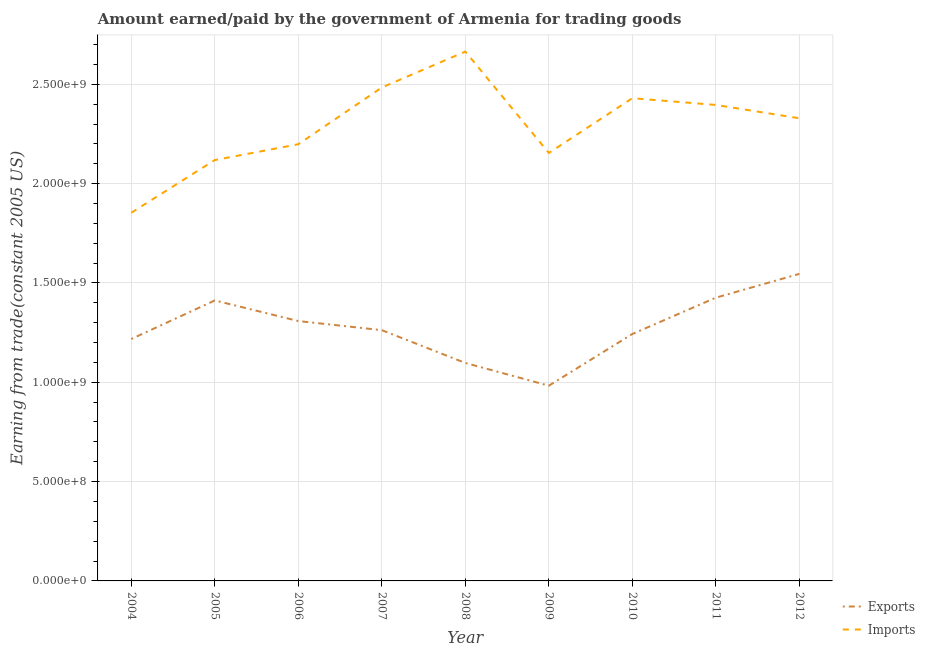Does the line corresponding to amount earned from exports intersect with the line corresponding to amount paid for imports?
Keep it short and to the point. No. What is the amount earned from exports in 2011?
Offer a terse response. 1.43e+09. Across all years, what is the maximum amount paid for imports?
Your answer should be very brief. 2.66e+09. Across all years, what is the minimum amount earned from exports?
Offer a terse response. 9.83e+08. In which year was the amount paid for imports minimum?
Make the answer very short. 2004. What is the total amount earned from exports in the graph?
Offer a terse response. 1.15e+1. What is the difference between the amount paid for imports in 2004 and that in 2009?
Your response must be concise. -3.01e+08. What is the difference between the amount earned from exports in 2010 and the amount paid for imports in 2007?
Your answer should be compact. -1.24e+09. What is the average amount paid for imports per year?
Ensure brevity in your answer.  2.29e+09. In the year 2009, what is the difference between the amount earned from exports and amount paid for imports?
Make the answer very short. -1.17e+09. In how many years, is the amount earned from exports greater than 1300000000 US$?
Keep it short and to the point. 4. What is the ratio of the amount paid for imports in 2008 to that in 2009?
Offer a terse response. 1.24. What is the difference between the highest and the second highest amount earned from exports?
Your response must be concise. 1.20e+08. What is the difference between the highest and the lowest amount earned from exports?
Ensure brevity in your answer.  5.63e+08. Is the sum of the amount earned from exports in 2004 and 2008 greater than the maximum amount paid for imports across all years?
Provide a succinct answer. No. Does the amount paid for imports monotonically increase over the years?
Provide a short and direct response. No. Is the amount earned from exports strictly greater than the amount paid for imports over the years?
Your answer should be compact. No. How many years are there in the graph?
Ensure brevity in your answer.  9. What is the difference between two consecutive major ticks on the Y-axis?
Ensure brevity in your answer.  5.00e+08. Where does the legend appear in the graph?
Provide a succinct answer. Bottom right. How many legend labels are there?
Offer a very short reply. 2. What is the title of the graph?
Give a very brief answer. Amount earned/paid by the government of Armenia for trading goods. Does "Time to import" appear as one of the legend labels in the graph?
Offer a terse response. No. What is the label or title of the Y-axis?
Provide a succinct answer. Earning from trade(constant 2005 US). What is the Earning from trade(constant 2005 US) of Exports in 2004?
Give a very brief answer. 1.22e+09. What is the Earning from trade(constant 2005 US) of Imports in 2004?
Provide a succinct answer. 1.85e+09. What is the Earning from trade(constant 2005 US) in Exports in 2005?
Give a very brief answer. 1.41e+09. What is the Earning from trade(constant 2005 US) in Imports in 2005?
Offer a very short reply. 2.12e+09. What is the Earning from trade(constant 2005 US) of Exports in 2006?
Your answer should be very brief. 1.31e+09. What is the Earning from trade(constant 2005 US) in Imports in 2006?
Your answer should be compact. 2.20e+09. What is the Earning from trade(constant 2005 US) of Exports in 2007?
Your response must be concise. 1.26e+09. What is the Earning from trade(constant 2005 US) of Imports in 2007?
Ensure brevity in your answer.  2.48e+09. What is the Earning from trade(constant 2005 US) of Exports in 2008?
Provide a short and direct response. 1.10e+09. What is the Earning from trade(constant 2005 US) of Imports in 2008?
Ensure brevity in your answer.  2.66e+09. What is the Earning from trade(constant 2005 US) in Exports in 2009?
Provide a succinct answer. 9.83e+08. What is the Earning from trade(constant 2005 US) of Imports in 2009?
Your response must be concise. 2.15e+09. What is the Earning from trade(constant 2005 US) of Exports in 2010?
Provide a succinct answer. 1.24e+09. What is the Earning from trade(constant 2005 US) of Imports in 2010?
Your answer should be very brief. 2.43e+09. What is the Earning from trade(constant 2005 US) of Exports in 2011?
Provide a short and direct response. 1.43e+09. What is the Earning from trade(constant 2005 US) in Imports in 2011?
Your answer should be very brief. 2.40e+09. What is the Earning from trade(constant 2005 US) in Exports in 2012?
Offer a terse response. 1.55e+09. What is the Earning from trade(constant 2005 US) of Imports in 2012?
Give a very brief answer. 2.33e+09. Across all years, what is the maximum Earning from trade(constant 2005 US) in Exports?
Provide a short and direct response. 1.55e+09. Across all years, what is the maximum Earning from trade(constant 2005 US) in Imports?
Keep it short and to the point. 2.66e+09. Across all years, what is the minimum Earning from trade(constant 2005 US) in Exports?
Make the answer very short. 9.83e+08. Across all years, what is the minimum Earning from trade(constant 2005 US) in Imports?
Provide a short and direct response. 1.85e+09. What is the total Earning from trade(constant 2005 US) of Exports in the graph?
Keep it short and to the point. 1.15e+1. What is the total Earning from trade(constant 2005 US) in Imports in the graph?
Provide a short and direct response. 2.06e+1. What is the difference between the Earning from trade(constant 2005 US) of Exports in 2004 and that in 2005?
Provide a short and direct response. -1.94e+08. What is the difference between the Earning from trade(constant 2005 US) of Imports in 2004 and that in 2005?
Your answer should be compact. -2.65e+08. What is the difference between the Earning from trade(constant 2005 US) in Exports in 2004 and that in 2006?
Ensure brevity in your answer.  -9.05e+07. What is the difference between the Earning from trade(constant 2005 US) of Imports in 2004 and that in 2006?
Offer a terse response. -3.45e+08. What is the difference between the Earning from trade(constant 2005 US) in Exports in 2004 and that in 2007?
Your response must be concise. -4.46e+07. What is the difference between the Earning from trade(constant 2005 US) of Imports in 2004 and that in 2007?
Your answer should be compact. -6.30e+08. What is the difference between the Earning from trade(constant 2005 US) in Exports in 2004 and that in 2008?
Offer a very short reply. 1.21e+08. What is the difference between the Earning from trade(constant 2005 US) in Imports in 2004 and that in 2008?
Your response must be concise. -8.11e+08. What is the difference between the Earning from trade(constant 2005 US) of Exports in 2004 and that in 2009?
Give a very brief answer. 2.35e+08. What is the difference between the Earning from trade(constant 2005 US) in Imports in 2004 and that in 2009?
Keep it short and to the point. -3.01e+08. What is the difference between the Earning from trade(constant 2005 US) in Exports in 2004 and that in 2010?
Give a very brief answer. -2.54e+07. What is the difference between the Earning from trade(constant 2005 US) of Imports in 2004 and that in 2010?
Provide a short and direct response. -5.77e+08. What is the difference between the Earning from trade(constant 2005 US) in Exports in 2004 and that in 2011?
Your answer should be compact. -2.08e+08. What is the difference between the Earning from trade(constant 2005 US) in Imports in 2004 and that in 2011?
Give a very brief answer. -5.43e+08. What is the difference between the Earning from trade(constant 2005 US) in Exports in 2004 and that in 2012?
Offer a terse response. -3.28e+08. What is the difference between the Earning from trade(constant 2005 US) in Imports in 2004 and that in 2012?
Provide a short and direct response. -4.75e+08. What is the difference between the Earning from trade(constant 2005 US) of Exports in 2005 and that in 2006?
Keep it short and to the point. 1.04e+08. What is the difference between the Earning from trade(constant 2005 US) of Imports in 2005 and that in 2006?
Provide a succinct answer. -7.97e+07. What is the difference between the Earning from trade(constant 2005 US) of Exports in 2005 and that in 2007?
Provide a short and direct response. 1.50e+08. What is the difference between the Earning from trade(constant 2005 US) in Imports in 2005 and that in 2007?
Make the answer very short. -3.65e+08. What is the difference between the Earning from trade(constant 2005 US) of Exports in 2005 and that in 2008?
Offer a terse response. 3.15e+08. What is the difference between the Earning from trade(constant 2005 US) of Imports in 2005 and that in 2008?
Give a very brief answer. -5.46e+08. What is the difference between the Earning from trade(constant 2005 US) in Exports in 2005 and that in 2009?
Your answer should be very brief. 4.29e+08. What is the difference between the Earning from trade(constant 2005 US) in Imports in 2005 and that in 2009?
Offer a very short reply. -3.57e+07. What is the difference between the Earning from trade(constant 2005 US) in Exports in 2005 and that in 2010?
Your response must be concise. 1.69e+08. What is the difference between the Earning from trade(constant 2005 US) in Imports in 2005 and that in 2010?
Provide a short and direct response. -3.11e+08. What is the difference between the Earning from trade(constant 2005 US) of Exports in 2005 and that in 2011?
Keep it short and to the point. -1.40e+07. What is the difference between the Earning from trade(constant 2005 US) in Imports in 2005 and that in 2011?
Provide a short and direct response. -2.77e+08. What is the difference between the Earning from trade(constant 2005 US) of Exports in 2005 and that in 2012?
Give a very brief answer. -1.34e+08. What is the difference between the Earning from trade(constant 2005 US) of Imports in 2005 and that in 2012?
Keep it short and to the point. -2.10e+08. What is the difference between the Earning from trade(constant 2005 US) in Exports in 2006 and that in 2007?
Your answer should be very brief. 4.59e+07. What is the difference between the Earning from trade(constant 2005 US) of Imports in 2006 and that in 2007?
Your answer should be very brief. -2.86e+08. What is the difference between the Earning from trade(constant 2005 US) of Exports in 2006 and that in 2008?
Give a very brief answer. 2.11e+08. What is the difference between the Earning from trade(constant 2005 US) in Imports in 2006 and that in 2008?
Your response must be concise. -4.66e+08. What is the difference between the Earning from trade(constant 2005 US) of Exports in 2006 and that in 2009?
Provide a short and direct response. 3.25e+08. What is the difference between the Earning from trade(constant 2005 US) of Imports in 2006 and that in 2009?
Offer a very short reply. 4.39e+07. What is the difference between the Earning from trade(constant 2005 US) in Exports in 2006 and that in 2010?
Your answer should be compact. 6.51e+07. What is the difference between the Earning from trade(constant 2005 US) in Imports in 2006 and that in 2010?
Provide a short and direct response. -2.32e+08. What is the difference between the Earning from trade(constant 2005 US) of Exports in 2006 and that in 2011?
Make the answer very short. -1.18e+08. What is the difference between the Earning from trade(constant 2005 US) in Imports in 2006 and that in 2011?
Your response must be concise. -1.98e+08. What is the difference between the Earning from trade(constant 2005 US) of Exports in 2006 and that in 2012?
Give a very brief answer. -2.37e+08. What is the difference between the Earning from trade(constant 2005 US) of Imports in 2006 and that in 2012?
Your response must be concise. -1.31e+08. What is the difference between the Earning from trade(constant 2005 US) in Exports in 2007 and that in 2008?
Give a very brief answer. 1.65e+08. What is the difference between the Earning from trade(constant 2005 US) in Imports in 2007 and that in 2008?
Your answer should be very brief. -1.81e+08. What is the difference between the Earning from trade(constant 2005 US) of Exports in 2007 and that in 2009?
Your answer should be very brief. 2.80e+08. What is the difference between the Earning from trade(constant 2005 US) in Imports in 2007 and that in 2009?
Give a very brief answer. 3.30e+08. What is the difference between the Earning from trade(constant 2005 US) of Exports in 2007 and that in 2010?
Provide a short and direct response. 1.92e+07. What is the difference between the Earning from trade(constant 2005 US) in Imports in 2007 and that in 2010?
Your answer should be very brief. 5.38e+07. What is the difference between the Earning from trade(constant 2005 US) in Exports in 2007 and that in 2011?
Offer a very short reply. -1.64e+08. What is the difference between the Earning from trade(constant 2005 US) in Imports in 2007 and that in 2011?
Provide a short and direct response. 8.79e+07. What is the difference between the Earning from trade(constant 2005 US) of Exports in 2007 and that in 2012?
Your answer should be very brief. -2.83e+08. What is the difference between the Earning from trade(constant 2005 US) of Imports in 2007 and that in 2012?
Provide a succinct answer. 1.55e+08. What is the difference between the Earning from trade(constant 2005 US) in Exports in 2008 and that in 2009?
Offer a terse response. 1.14e+08. What is the difference between the Earning from trade(constant 2005 US) in Imports in 2008 and that in 2009?
Your response must be concise. 5.10e+08. What is the difference between the Earning from trade(constant 2005 US) in Exports in 2008 and that in 2010?
Your answer should be compact. -1.46e+08. What is the difference between the Earning from trade(constant 2005 US) in Imports in 2008 and that in 2010?
Provide a succinct answer. 2.35e+08. What is the difference between the Earning from trade(constant 2005 US) of Exports in 2008 and that in 2011?
Give a very brief answer. -3.29e+08. What is the difference between the Earning from trade(constant 2005 US) in Imports in 2008 and that in 2011?
Offer a very short reply. 2.69e+08. What is the difference between the Earning from trade(constant 2005 US) of Exports in 2008 and that in 2012?
Ensure brevity in your answer.  -4.48e+08. What is the difference between the Earning from trade(constant 2005 US) in Imports in 2008 and that in 2012?
Give a very brief answer. 3.36e+08. What is the difference between the Earning from trade(constant 2005 US) of Exports in 2009 and that in 2010?
Your response must be concise. -2.60e+08. What is the difference between the Earning from trade(constant 2005 US) of Imports in 2009 and that in 2010?
Make the answer very short. -2.76e+08. What is the difference between the Earning from trade(constant 2005 US) in Exports in 2009 and that in 2011?
Provide a succinct answer. -4.43e+08. What is the difference between the Earning from trade(constant 2005 US) in Imports in 2009 and that in 2011?
Offer a terse response. -2.42e+08. What is the difference between the Earning from trade(constant 2005 US) in Exports in 2009 and that in 2012?
Provide a short and direct response. -5.63e+08. What is the difference between the Earning from trade(constant 2005 US) of Imports in 2009 and that in 2012?
Keep it short and to the point. -1.75e+08. What is the difference between the Earning from trade(constant 2005 US) in Exports in 2010 and that in 2011?
Offer a very short reply. -1.83e+08. What is the difference between the Earning from trade(constant 2005 US) of Imports in 2010 and that in 2011?
Provide a short and direct response. 3.40e+07. What is the difference between the Earning from trade(constant 2005 US) of Exports in 2010 and that in 2012?
Make the answer very short. -3.03e+08. What is the difference between the Earning from trade(constant 2005 US) of Imports in 2010 and that in 2012?
Your answer should be compact. 1.01e+08. What is the difference between the Earning from trade(constant 2005 US) of Exports in 2011 and that in 2012?
Offer a terse response. -1.20e+08. What is the difference between the Earning from trade(constant 2005 US) of Imports in 2011 and that in 2012?
Ensure brevity in your answer.  6.71e+07. What is the difference between the Earning from trade(constant 2005 US) in Exports in 2004 and the Earning from trade(constant 2005 US) in Imports in 2005?
Make the answer very short. -9.01e+08. What is the difference between the Earning from trade(constant 2005 US) of Exports in 2004 and the Earning from trade(constant 2005 US) of Imports in 2006?
Make the answer very short. -9.80e+08. What is the difference between the Earning from trade(constant 2005 US) of Exports in 2004 and the Earning from trade(constant 2005 US) of Imports in 2007?
Your answer should be very brief. -1.27e+09. What is the difference between the Earning from trade(constant 2005 US) of Exports in 2004 and the Earning from trade(constant 2005 US) of Imports in 2008?
Your answer should be very brief. -1.45e+09. What is the difference between the Earning from trade(constant 2005 US) in Exports in 2004 and the Earning from trade(constant 2005 US) in Imports in 2009?
Keep it short and to the point. -9.36e+08. What is the difference between the Earning from trade(constant 2005 US) in Exports in 2004 and the Earning from trade(constant 2005 US) in Imports in 2010?
Offer a very short reply. -1.21e+09. What is the difference between the Earning from trade(constant 2005 US) in Exports in 2004 and the Earning from trade(constant 2005 US) in Imports in 2011?
Keep it short and to the point. -1.18e+09. What is the difference between the Earning from trade(constant 2005 US) of Exports in 2004 and the Earning from trade(constant 2005 US) of Imports in 2012?
Your response must be concise. -1.11e+09. What is the difference between the Earning from trade(constant 2005 US) of Exports in 2005 and the Earning from trade(constant 2005 US) of Imports in 2006?
Your answer should be very brief. -7.86e+08. What is the difference between the Earning from trade(constant 2005 US) in Exports in 2005 and the Earning from trade(constant 2005 US) in Imports in 2007?
Give a very brief answer. -1.07e+09. What is the difference between the Earning from trade(constant 2005 US) in Exports in 2005 and the Earning from trade(constant 2005 US) in Imports in 2008?
Make the answer very short. -1.25e+09. What is the difference between the Earning from trade(constant 2005 US) of Exports in 2005 and the Earning from trade(constant 2005 US) of Imports in 2009?
Your answer should be very brief. -7.42e+08. What is the difference between the Earning from trade(constant 2005 US) in Exports in 2005 and the Earning from trade(constant 2005 US) in Imports in 2010?
Provide a succinct answer. -1.02e+09. What is the difference between the Earning from trade(constant 2005 US) in Exports in 2005 and the Earning from trade(constant 2005 US) in Imports in 2011?
Provide a succinct answer. -9.84e+08. What is the difference between the Earning from trade(constant 2005 US) of Exports in 2005 and the Earning from trade(constant 2005 US) of Imports in 2012?
Ensure brevity in your answer.  -9.17e+08. What is the difference between the Earning from trade(constant 2005 US) of Exports in 2006 and the Earning from trade(constant 2005 US) of Imports in 2007?
Your response must be concise. -1.18e+09. What is the difference between the Earning from trade(constant 2005 US) in Exports in 2006 and the Earning from trade(constant 2005 US) in Imports in 2008?
Your answer should be compact. -1.36e+09. What is the difference between the Earning from trade(constant 2005 US) of Exports in 2006 and the Earning from trade(constant 2005 US) of Imports in 2009?
Your response must be concise. -8.46e+08. What is the difference between the Earning from trade(constant 2005 US) in Exports in 2006 and the Earning from trade(constant 2005 US) in Imports in 2010?
Provide a short and direct response. -1.12e+09. What is the difference between the Earning from trade(constant 2005 US) in Exports in 2006 and the Earning from trade(constant 2005 US) in Imports in 2011?
Your response must be concise. -1.09e+09. What is the difference between the Earning from trade(constant 2005 US) of Exports in 2006 and the Earning from trade(constant 2005 US) of Imports in 2012?
Keep it short and to the point. -1.02e+09. What is the difference between the Earning from trade(constant 2005 US) in Exports in 2007 and the Earning from trade(constant 2005 US) in Imports in 2008?
Keep it short and to the point. -1.40e+09. What is the difference between the Earning from trade(constant 2005 US) in Exports in 2007 and the Earning from trade(constant 2005 US) in Imports in 2009?
Give a very brief answer. -8.92e+08. What is the difference between the Earning from trade(constant 2005 US) of Exports in 2007 and the Earning from trade(constant 2005 US) of Imports in 2010?
Your answer should be compact. -1.17e+09. What is the difference between the Earning from trade(constant 2005 US) of Exports in 2007 and the Earning from trade(constant 2005 US) of Imports in 2011?
Provide a short and direct response. -1.13e+09. What is the difference between the Earning from trade(constant 2005 US) of Exports in 2007 and the Earning from trade(constant 2005 US) of Imports in 2012?
Keep it short and to the point. -1.07e+09. What is the difference between the Earning from trade(constant 2005 US) in Exports in 2008 and the Earning from trade(constant 2005 US) in Imports in 2009?
Offer a very short reply. -1.06e+09. What is the difference between the Earning from trade(constant 2005 US) of Exports in 2008 and the Earning from trade(constant 2005 US) of Imports in 2010?
Your answer should be compact. -1.33e+09. What is the difference between the Earning from trade(constant 2005 US) of Exports in 2008 and the Earning from trade(constant 2005 US) of Imports in 2011?
Give a very brief answer. -1.30e+09. What is the difference between the Earning from trade(constant 2005 US) in Exports in 2008 and the Earning from trade(constant 2005 US) in Imports in 2012?
Ensure brevity in your answer.  -1.23e+09. What is the difference between the Earning from trade(constant 2005 US) of Exports in 2009 and the Earning from trade(constant 2005 US) of Imports in 2010?
Give a very brief answer. -1.45e+09. What is the difference between the Earning from trade(constant 2005 US) in Exports in 2009 and the Earning from trade(constant 2005 US) in Imports in 2011?
Keep it short and to the point. -1.41e+09. What is the difference between the Earning from trade(constant 2005 US) of Exports in 2009 and the Earning from trade(constant 2005 US) of Imports in 2012?
Make the answer very short. -1.35e+09. What is the difference between the Earning from trade(constant 2005 US) of Exports in 2010 and the Earning from trade(constant 2005 US) of Imports in 2011?
Provide a succinct answer. -1.15e+09. What is the difference between the Earning from trade(constant 2005 US) in Exports in 2010 and the Earning from trade(constant 2005 US) in Imports in 2012?
Ensure brevity in your answer.  -1.09e+09. What is the difference between the Earning from trade(constant 2005 US) of Exports in 2011 and the Earning from trade(constant 2005 US) of Imports in 2012?
Make the answer very short. -9.03e+08. What is the average Earning from trade(constant 2005 US) of Exports per year?
Your answer should be compact. 1.28e+09. What is the average Earning from trade(constant 2005 US) in Imports per year?
Make the answer very short. 2.29e+09. In the year 2004, what is the difference between the Earning from trade(constant 2005 US) of Exports and Earning from trade(constant 2005 US) of Imports?
Your answer should be very brief. -6.36e+08. In the year 2005, what is the difference between the Earning from trade(constant 2005 US) in Exports and Earning from trade(constant 2005 US) in Imports?
Give a very brief answer. -7.07e+08. In the year 2006, what is the difference between the Earning from trade(constant 2005 US) in Exports and Earning from trade(constant 2005 US) in Imports?
Your response must be concise. -8.90e+08. In the year 2007, what is the difference between the Earning from trade(constant 2005 US) of Exports and Earning from trade(constant 2005 US) of Imports?
Your answer should be very brief. -1.22e+09. In the year 2008, what is the difference between the Earning from trade(constant 2005 US) in Exports and Earning from trade(constant 2005 US) in Imports?
Provide a short and direct response. -1.57e+09. In the year 2009, what is the difference between the Earning from trade(constant 2005 US) in Exports and Earning from trade(constant 2005 US) in Imports?
Offer a terse response. -1.17e+09. In the year 2010, what is the difference between the Earning from trade(constant 2005 US) in Exports and Earning from trade(constant 2005 US) in Imports?
Keep it short and to the point. -1.19e+09. In the year 2011, what is the difference between the Earning from trade(constant 2005 US) of Exports and Earning from trade(constant 2005 US) of Imports?
Your answer should be compact. -9.70e+08. In the year 2012, what is the difference between the Earning from trade(constant 2005 US) of Exports and Earning from trade(constant 2005 US) of Imports?
Offer a very short reply. -7.83e+08. What is the ratio of the Earning from trade(constant 2005 US) in Exports in 2004 to that in 2005?
Provide a short and direct response. 0.86. What is the ratio of the Earning from trade(constant 2005 US) of Imports in 2004 to that in 2005?
Keep it short and to the point. 0.87. What is the ratio of the Earning from trade(constant 2005 US) of Exports in 2004 to that in 2006?
Offer a terse response. 0.93. What is the ratio of the Earning from trade(constant 2005 US) in Imports in 2004 to that in 2006?
Your answer should be compact. 0.84. What is the ratio of the Earning from trade(constant 2005 US) of Exports in 2004 to that in 2007?
Offer a very short reply. 0.96. What is the ratio of the Earning from trade(constant 2005 US) in Imports in 2004 to that in 2007?
Your answer should be compact. 0.75. What is the ratio of the Earning from trade(constant 2005 US) in Exports in 2004 to that in 2008?
Provide a short and direct response. 1.11. What is the ratio of the Earning from trade(constant 2005 US) of Imports in 2004 to that in 2008?
Your answer should be compact. 0.7. What is the ratio of the Earning from trade(constant 2005 US) in Exports in 2004 to that in 2009?
Give a very brief answer. 1.24. What is the ratio of the Earning from trade(constant 2005 US) in Imports in 2004 to that in 2009?
Offer a terse response. 0.86. What is the ratio of the Earning from trade(constant 2005 US) in Exports in 2004 to that in 2010?
Offer a terse response. 0.98. What is the ratio of the Earning from trade(constant 2005 US) in Imports in 2004 to that in 2010?
Your answer should be very brief. 0.76. What is the ratio of the Earning from trade(constant 2005 US) of Exports in 2004 to that in 2011?
Ensure brevity in your answer.  0.85. What is the ratio of the Earning from trade(constant 2005 US) in Imports in 2004 to that in 2011?
Your answer should be very brief. 0.77. What is the ratio of the Earning from trade(constant 2005 US) of Exports in 2004 to that in 2012?
Give a very brief answer. 0.79. What is the ratio of the Earning from trade(constant 2005 US) in Imports in 2004 to that in 2012?
Your response must be concise. 0.8. What is the ratio of the Earning from trade(constant 2005 US) of Exports in 2005 to that in 2006?
Keep it short and to the point. 1.08. What is the ratio of the Earning from trade(constant 2005 US) in Imports in 2005 to that in 2006?
Offer a terse response. 0.96. What is the ratio of the Earning from trade(constant 2005 US) in Exports in 2005 to that in 2007?
Provide a succinct answer. 1.12. What is the ratio of the Earning from trade(constant 2005 US) in Imports in 2005 to that in 2007?
Provide a succinct answer. 0.85. What is the ratio of the Earning from trade(constant 2005 US) in Exports in 2005 to that in 2008?
Keep it short and to the point. 1.29. What is the ratio of the Earning from trade(constant 2005 US) of Imports in 2005 to that in 2008?
Provide a short and direct response. 0.8. What is the ratio of the Earning from trade(constant 2005 US) of Exports in 2005 to that in 2009?
Ensure brevity in your answer.  1.44. What is the ratio of the Earning from trade(constant 2005 US) of Imports in 2005 to that in 2009?
Provide a succinct answer. 0.98. What is the ratio of the Earning from trade(constant 2005 US) in Exports in 2005 to that in 2010?
Provide a short and direct response. 1.14. What is the ratio of the Earning from trade(constant 2005 US) of Imports in 2005 to that in 2010?
Your response must be concise. 0.87. What is the ratio of the Earning from trade(constant 2005 US) of Exports in 2005 to that in 2011?
Your answer should be compact. 0.99. What is the ratio of the Earning from trade(constant 2005 US) in Imports in 2005 to that in 2011?
Your response must be concise. 0.88. What is the ratio of the Earning from trade(constant 2005 US) of Exports in 2005 to that in 2012?
Provide a succinct answer. 0.91. What is the ratio of the Earning from trade(constant 2005 US) of Imports in 2005 to that in 2012?
Ensure brevity in your answer.  0.91. What is the ratio of the Earning from trade(constant 2005 US) in Exports in 2006 to that in 2007?
Provide a succinct answer. 1.04. What is the ratio of the Earning from trade(constant 2005 US) in Imports in 2006 to that in 2007?
Your response must be concise. 0.89. What is the ratio of the Earning from trade(constant 2005 US) of Exports in 2006 to that in 2008?
Provide a succinct answer. 1.19. What is the ratio of the Earning from trade(constant 2005 US) of Imports in 2006 to that in 2008?
Make the answer very short. 0.82. What is the ratio of the Earning from trade(constant 2005 US) in Exports in 2006 to that in 2009?
Keep it short and to the point. 1.33. What is the ratio of the Earning from trade(constant 2005 US) of Imports in 2006 to that in 2009?
Make the answer very short. 1.02. What is the ratio of the Earning from trade(constant 2005 US) in Exports in 2006 to that in 2010?
Offer a terse response. 1.05. What is the ratio of the Earning from trade(constant 2005 US) in Imports in 2006 to that in 2010?
Provide a short and direct response. 0.9. What is the ratio of the Earning from trade(constant 2005 US) in Exports in 2006 to that in 2011?
Keep it short and to the point. 0.92. What is the ratio of the Earning from trade(constant 2005 US) of Imports in 2006 to that in 2011?
Offer a terse response. 0.92. What is the ratio of the Earning from trade(constant 2005 US) in Exports in 2006 to that in 2012?
Your response must be concise. 0.85. What is the ratio of the Earning from trade(constant 2005 US) of Imports in 2006 to that in 2012?
Make the answer very short. 0.94. What is the ratio of the Earning from trade(constant 2005 US) of Exports in 2007 to that in 2008?
Give a very brief answer. 1.15. What is the ratio of the Earning from trade(constant 2005 US) of Imports in 2007 to that in 2008?
Give a very brief answer. 0.93. What is the ratio of the Earning from trade(constant 2005 US) of Exports in 2007 to that in 2009?
Your answer should be compact. 1.28. What is the ratio of the Earning from trade(constant 2005 US) of Imports in 2007 to that in 2009?
Your response must be concise. 1.15. What is the ratio of the Earning from trade(constant 2005 US) of Exports in 2007 to that in 2010?
Ensure brevity in your answer.  1.02. What is the ratio of the Earning from trade(constant 2005 US) of Imports in 2007 to that in 2010?
Ensure brevity in your answer.  1.02. What is the ratio of the Earning from trade(constant 2005 US) of Exports in 2007 to that in 2011?
Provide a short and direct response. 0.89. What is the ratio of the Earning from trade(constant 2005 US) in Imports in 2007 to that in 2011?
Ensure brevity in your answer.  1.04. What is the ratio of the Earning from trade(constant 2005 US) in Exports in 2007 to that in 2012?
Ensure brevity in your answer.  0.82. What is the ratio of the Earning from trade(constant 2005 US) in Imports in 2007 to that in 2012?
Your answer should be compact. 1.07. What is the ratio of the Earning from trade(constant 2005 US) in Exports in 2008 to that in 2009?
Keep it short and to the point. 1.12. What is the ratio of the Earning from trade(constant 2005 US) in Imports in 2008 to that in 2009?
Make the answer very short. 1.24. What is the ratio of the Earning from trade(constant 2005 US) in Exports in 2008 to that in 2010?
Offer a very short reply. 0.88. What is the ratio of the Earning from trade(constant 2005 US) in Imports in 2008 to that in 2010?
Keep it short and to the point. 1.1. What is the ratio of the Earning from trade(constant 2005 US) of Exports in 2008 to that in 2011?
Ensure brevity in your answer.  0.77. What is the ratio of the Earning from trade(constant 2005 US) of Imports in 2008 to that in 2011?
Ensure brevity in your answer.  1.11. What is the ratio of the Earning from trade(constant 2005 US) in Exports in 2008 to that in 2012?
Provide a short and direct response. 0.71. What is the ratio of the Earning from trade(constant 2005 US) of Imports in 2008 to that in 2012?
Make the answer very short. 1.14. What is the ratio of the Earning from trade(constant 2005 US) of Exports in 2009 to that in 2010?
Your response must be concise. 0.79. What is the ratio of the Earning from trade(constant 2005 US) of Imports in 2009 to that in 2010?
Your answer should be very brief. 0.89. What is the ratio of the Earning from trade(constant 2005 US) of Exports in 2009 to that in 2011?
Your answer should be compact. 0.69. What is the ratio of the Earning from trade(constant 2005 US) of Imports in 2009 to that in 2011?
Offer a terse response. 0.9. What is the ratio of the Earning from trade(constant 2005 US) in Exports in 2009 to that in 2012?
Give a very brief answer. 0.64. What is the ratio of the Earning from trade(constant 2005 US) of Imports in 2009 to that in 2012?
Provide a short and direct response. 0.93. What is the ratio of the Earning from trade(constant 2005 US) in Exports in 2010 to that in 2011?
Your answer should be compact. 0.87. What is the ratio of the Earning from trade(constant 2005 US) in Imports in 2010 to that in 2011?
Provide a succinct answer. 1.01. What is the ratio of the Earning from trade(constant 2005 US) of Exports in 2010 to that in 2012?
Provide a short and direct response. 0.8. What is the ratio of the Earning from trade(constant 2005 US) of Imports in 2010 to that in 2012?
Give a very brief answer. 1.04. What is the ratio of the Earning from trade(constant 2005 US) in Exports in 2011 to that in 2012?
Offer a very short reply. 0.92. What is the ratio of the Earning from trade(constant 2005 US) of Imports in 2011 to that in 2012?
Keep it short and to the point. 1.03. What is the difference between the highest and the second highest Earning from trade(constant 2005 US) in Exports?
Your answer should be compact. 1.20e+08. What is the difference between the highest and the second highest Earning from trade(constant 2005 US) of Imports?
Offer a very short reply. 1.81e+08. What is the difference between the highest and the lowest Earning from trade(constant 2005 US) of Exports?
Provide a succinct answer. 5.63e+08. What is the difference between the highest and the lowest Earning from trade(constant 2005 US) in Imports?
Your answer should be very brief. 8.11e+08. 